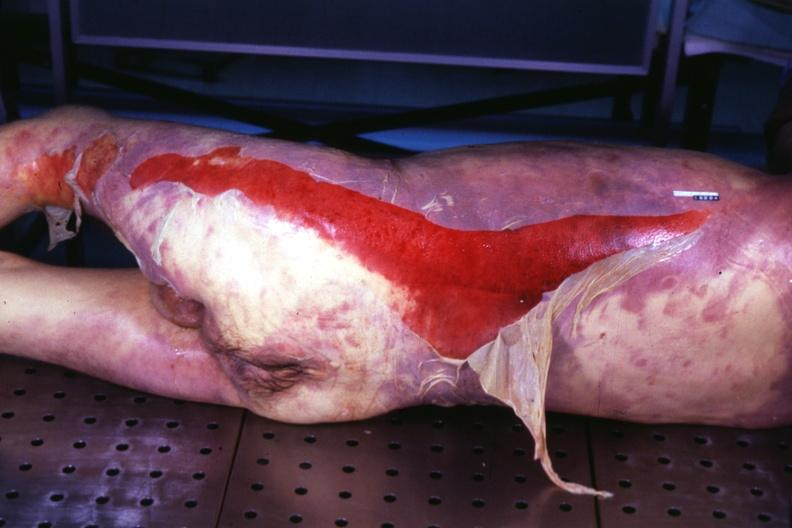how does this image show body?
Answer the question using a single word or phrase. With extensive ecchymoses and desquamation 